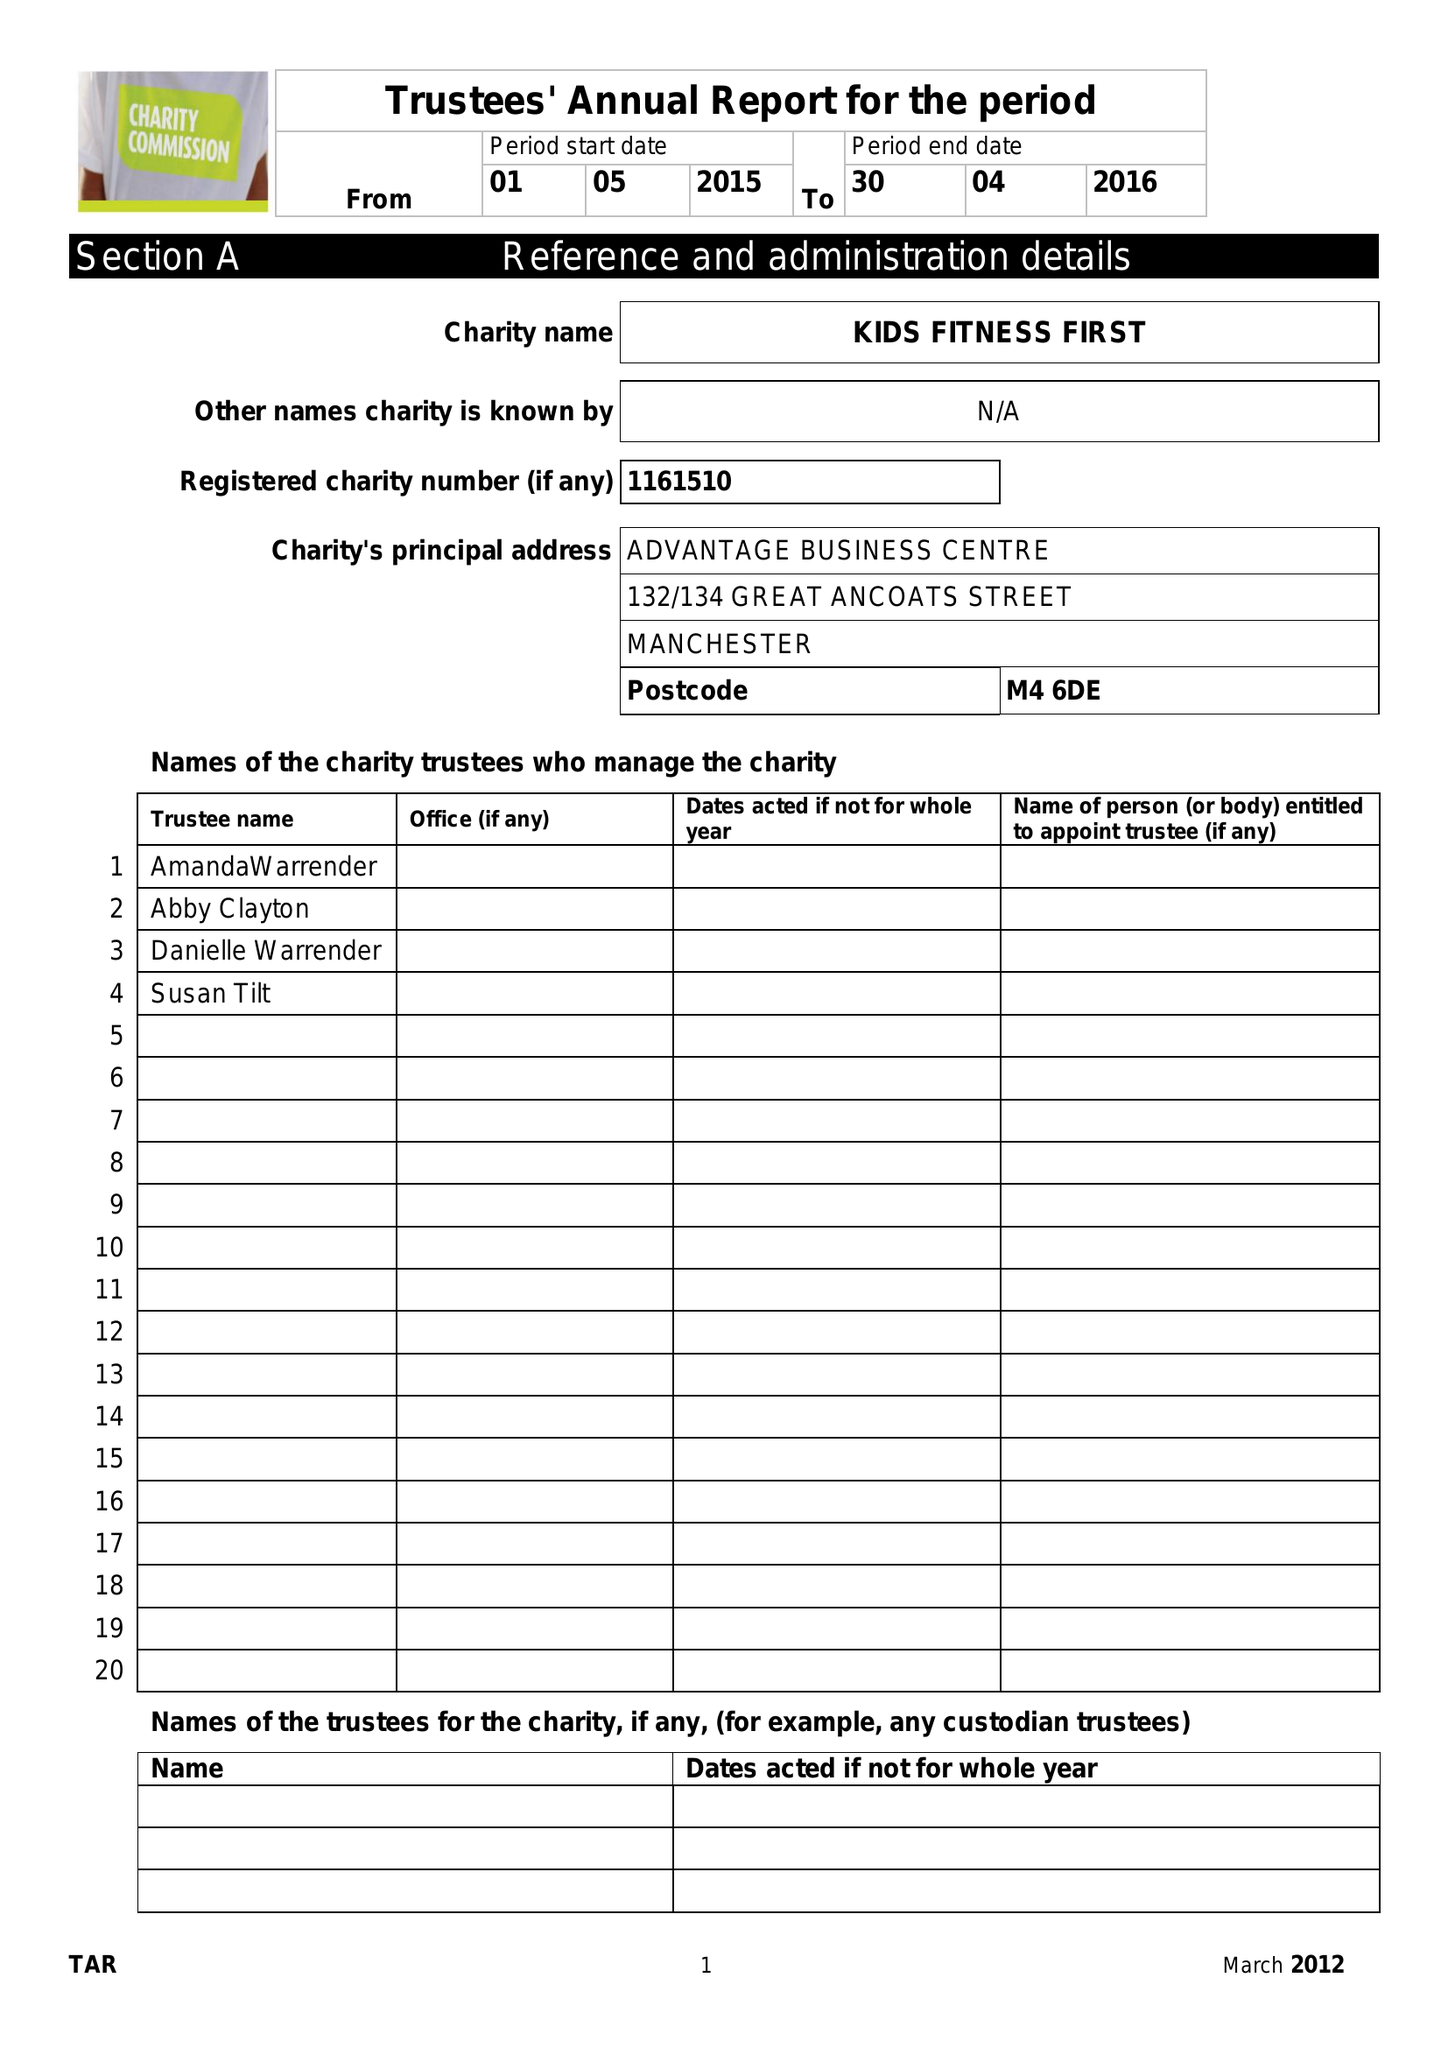What is the value for the address__street_line?
Answer the question using a single word or phrase. 132-134 GREAT ANCOATS STREET 